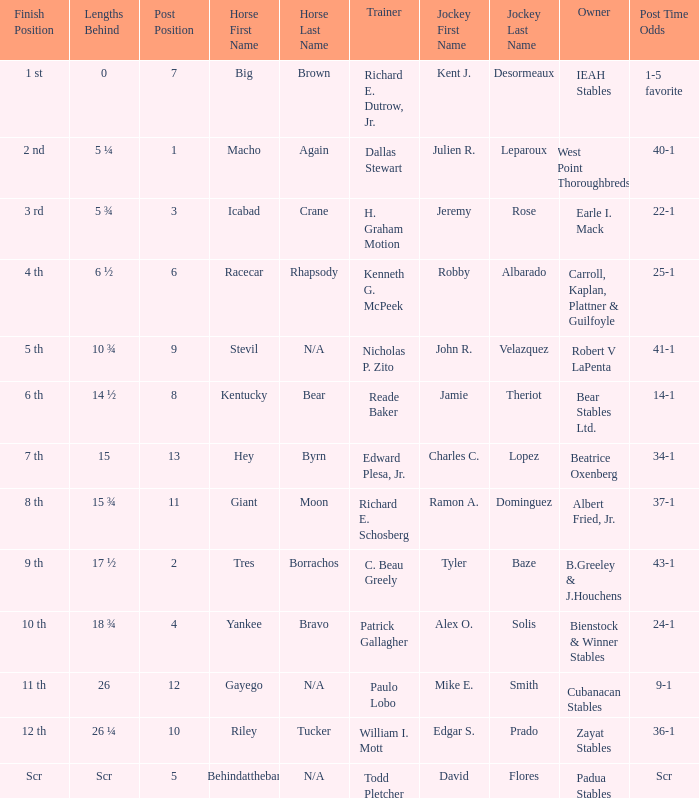What's the post position when the lengths behind is 0? 7.0. 